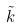<formula> <loc_0><loc_0><loc_500><loc_500>\tilde { k }</formula> 